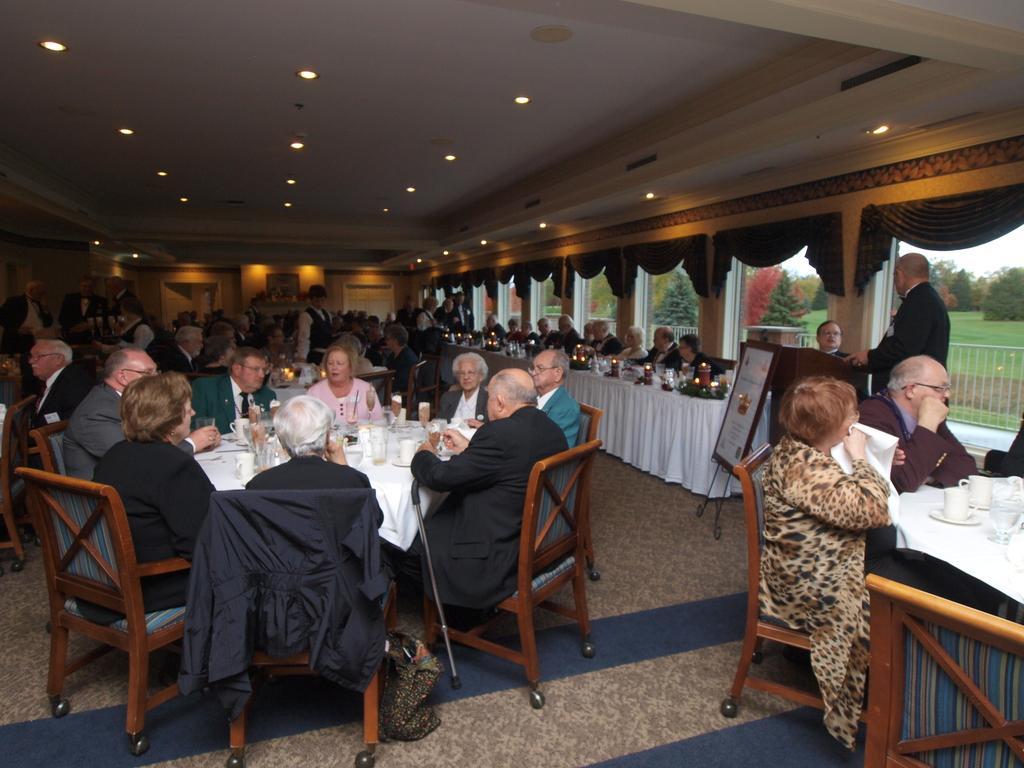Could you give a brief overview of what you see in this image? In this image i can see group of people sitting on a chair there are few glasses on a table, table covered with a white cloth, at the right i can see few candles and some food items on the table and some people sitting, here at the back ground some persons are standing at right i can see a podium and a pole, at the back ground i can see a brown curtain, trees,sky at the top there is a light. 